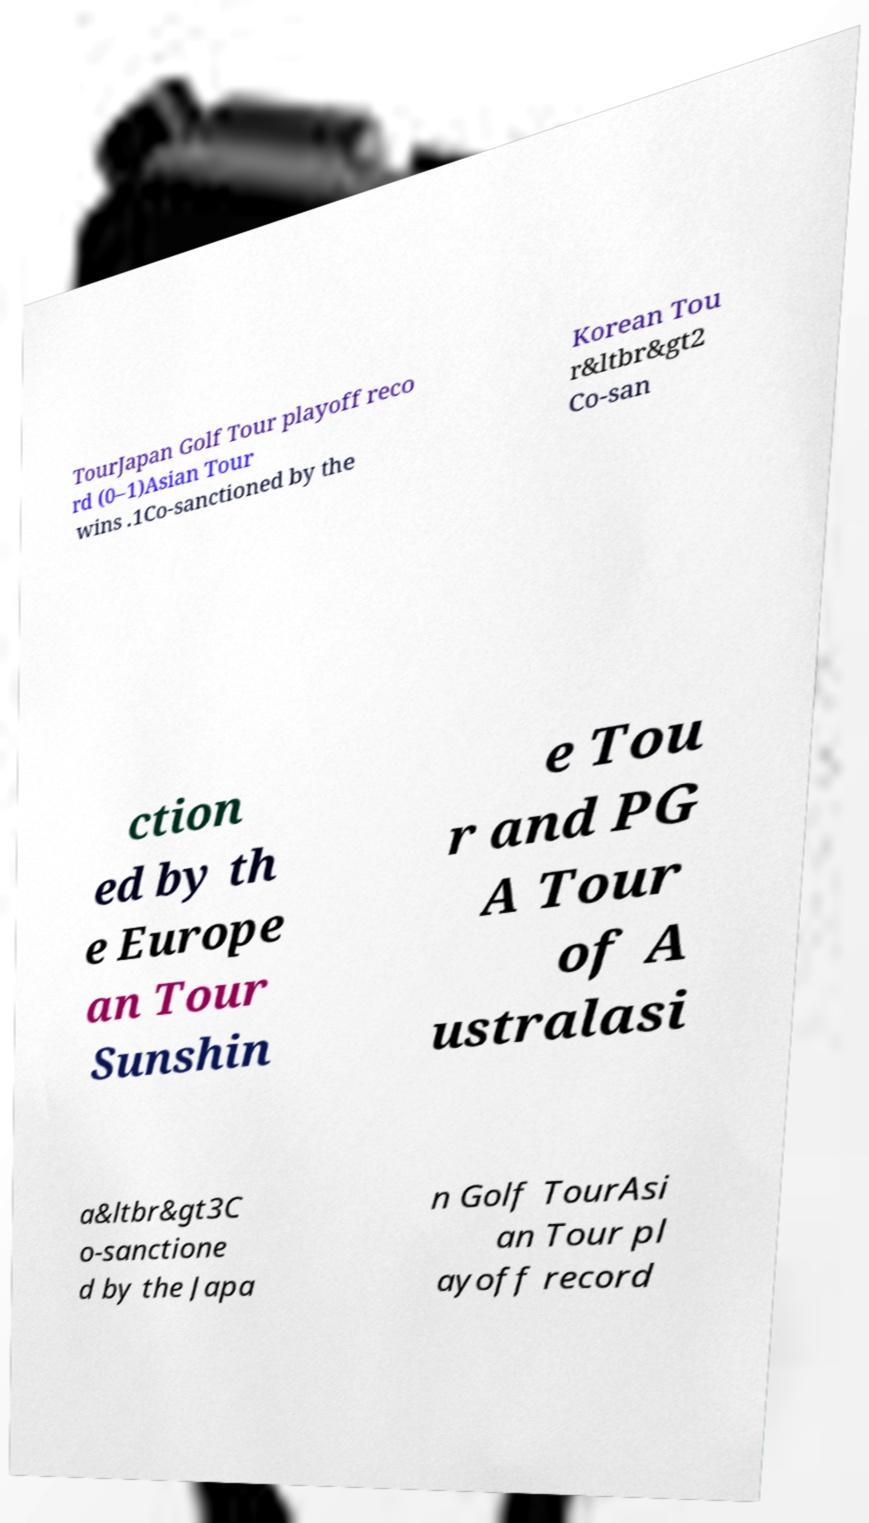What messages or text are displayed in this image? I need them in a readable, typed format. TourJapan Golf Tour playoff reco rd (0–1)Asian Tour wins .1Co-sanctioned by the Korean Tou r&ltbr&gt2 Co-san ction ed by th e Europe an Tour Sunshin e Tou r and PG A Tour of A ustralasi a&ltbr&gt3C o-sanctione d by the Japa n Golf TourAsi an Tour pl ayoff record 